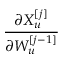Convert formula to latex. <formula><loc_0><loc_0><loc_500><loc_500>\frac { \partial X _ { u } ^ { [ j ] } } { \partial W _ { u } ^ { [ j - 1 ] } }</formula> 